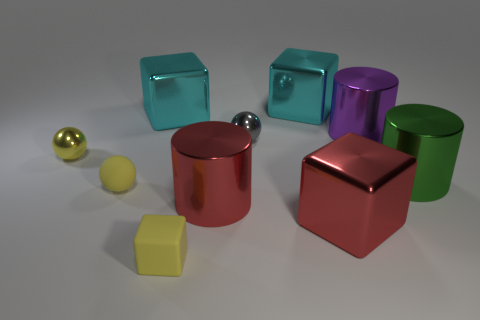Can you describe the materials and shapes of the objects seen in the image? Certainly, there are various geometric shapes present, such as cubes, cylinders, and spheres, made from materials with different finishes suggesting metallic and rubber textures. Specifically, there are translucent teal cubes, opaque colorful cylinders, a shiny silver sphere, and matte yellow and gold spheres. 